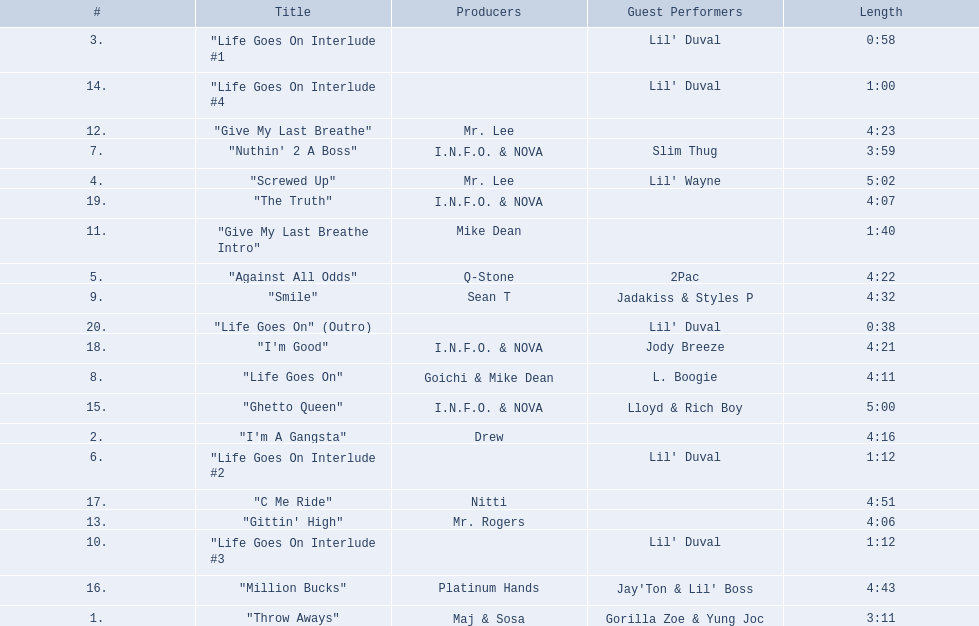What are the song lengths of all the songs on the album? 3:11, 4:16, 0:58, 5:02, 4:22, 1:12, 3:59, 4:11, 4:32, 1:12, 1:40, 4:23, 4:06, 1:00, 5:00, 4:43, 4:51, 4:21, 4:07, 0:38. Which is the longest of these? 5:02. 